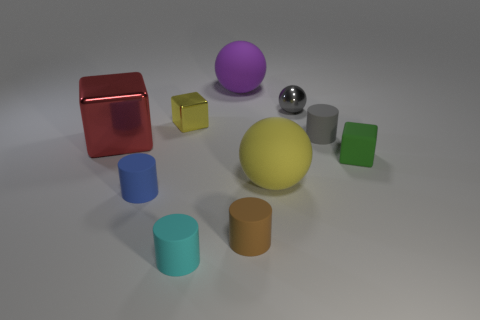The cyan rubber thing has what shape?
Your answer should be very brief. Cylinder. There is a cylinder left of the cyan matte cylinder; is its size the same as the metal cube on the left side of the small yellow thing?
Provide a succinct answer. No. There is a shiny block in front of the small rubber cylinder behind the rubber ball in front of the gray matte cylinder; what is its size?
Offer a very short reply. Large. What shape is the tiny metal object to the right of the purple matte sphere left of the yellow thing that is in front of the rubber cube?
Your response must be concise. Sphere. The yellow thing on the right side of the small cyan thing has what shape?
Ensure brevity in your answer.  Sphere. Is the small yellow object made of the same material as the big red block to the left of the gray rubber object?
Your answer should be compact. Yes. What number of other things are the same shape as the big metallic thing?
Offer a terse response. 2. There is a large metallic cube; is it the same color as the ball that is in front of the tiny green object?
Offer a very short reply. No. Are there any other things that are the same material as the big yellow sphere?
Provide a succinct answer. Yes. What shape is the metallic thing on the right side of the big purple matte sphere that is to the right of the big red metal block?
Keep it short and to the point. Sphere. 